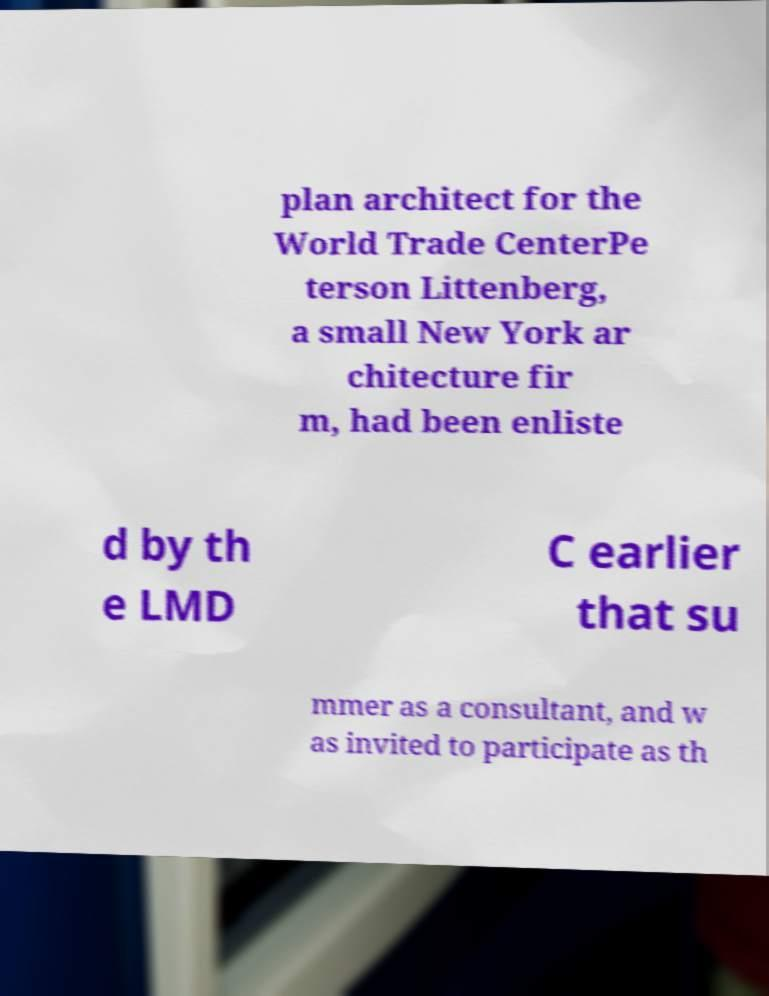What messages or text are displayed in this image? I need them in a readable, typed format. plan architect for the World Trade CenterPe terson Littenberg, a small New York ar chitecture fir m, had been enliste d by th e LMD C earlier that su mmer as a consultant, and w as invited to participate as th 